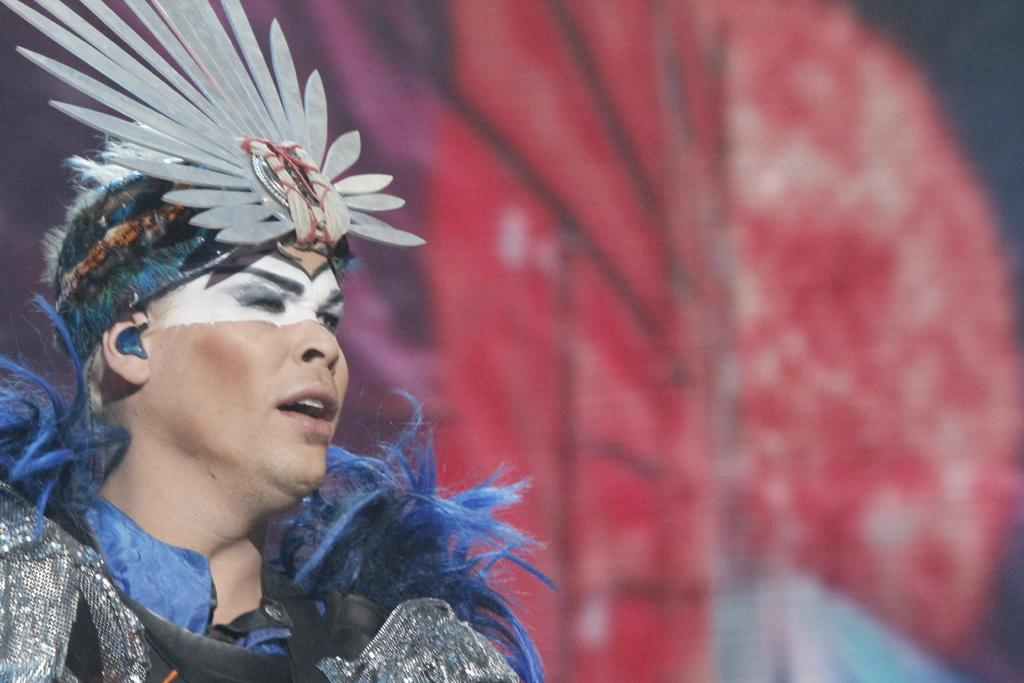Who is present in the image? There is a woman in the image. What is the woman wearing? The woman is wearing a blue dress. Can you describe the background of the image? The background of the image is blurred. What type of print can be seen on the cave walls in the image? There is no cave or print present in the image; it features a woman wearing a blue dress with a blurred background. 